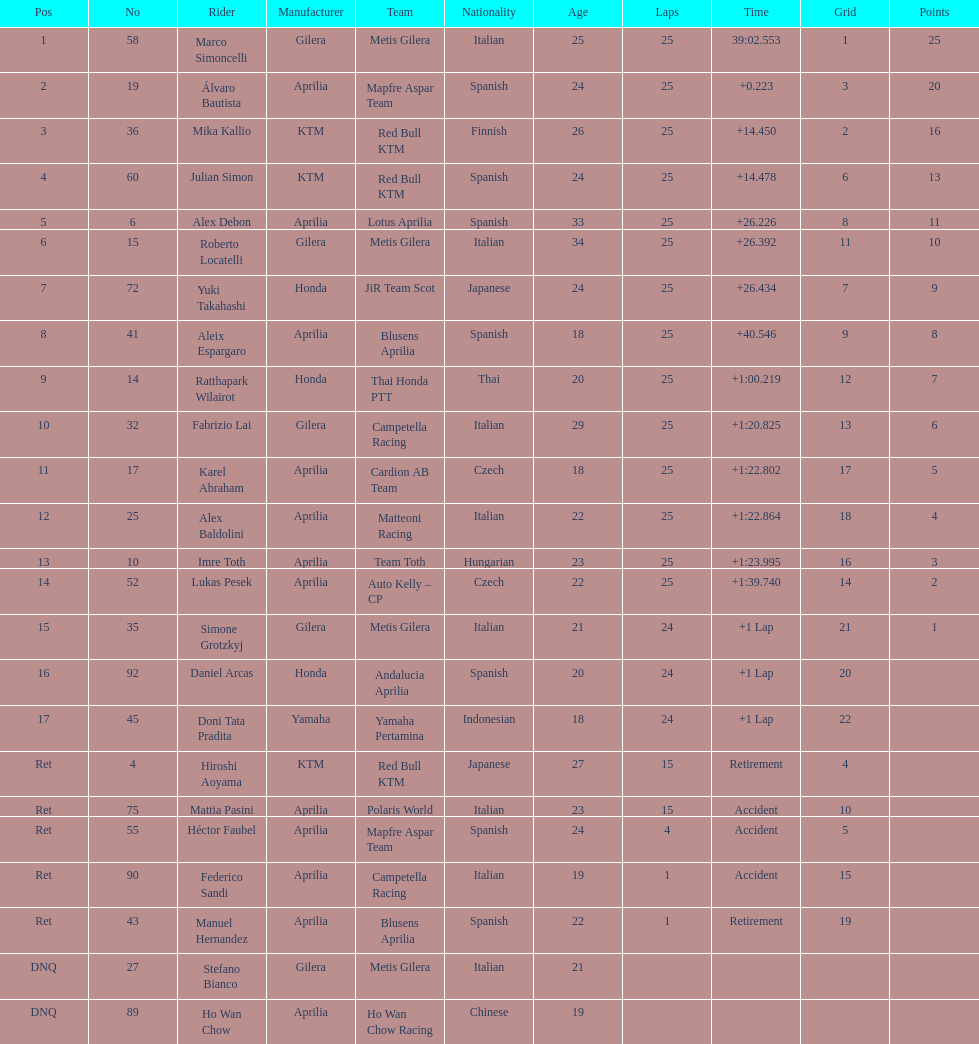Who perfomed the most number of laps, marco simoncelli or hiroshi aoyama? Marco Simoncelli. 